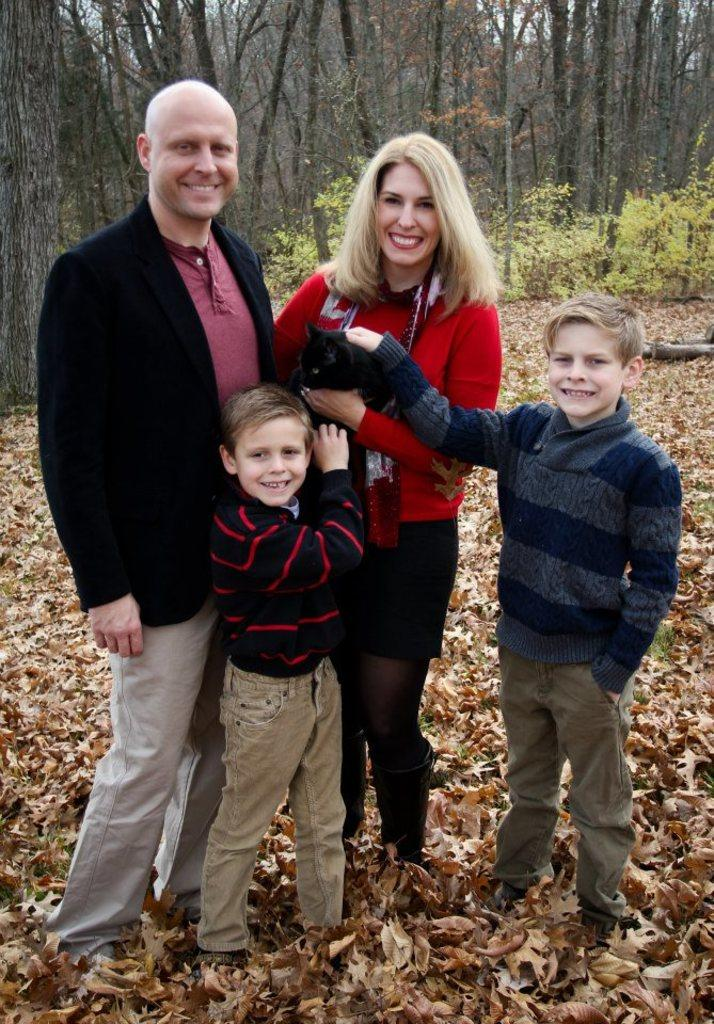How many people are in the image, and what are their genders? There are four people in the image: two men, two women, and two boys. What are the people in the image doing? The people are attempting to catch a cat. What type of natural environment is depicted in the image? There are many trees and plants in the image, and dry leaves are present. How many sheep can be seen in the image? There are no sheep present in the image. Is the grandfather in the image trying to help catch the cat? There is no mention of a grandfather in the image, so it cannot be determined if they are trying to help catch the cat. 